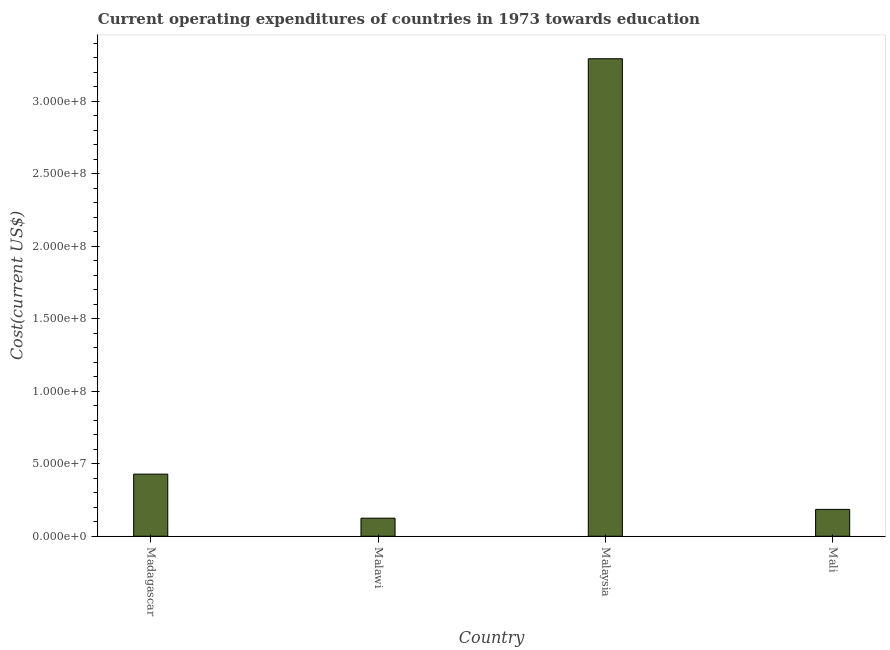Does the graph contain any zero values?
Offer a terse response. No. What is the title of the graph?
Give a very brief answer. Current operating expenditures of countries in 1973 towards education. What is the label or title of the X-axis?
Provide a short and direct response. Country. What is the label or title of the Y-axis?
Provide a short and direct response. Cost(current US$). What is the education expenditure in Malawi?
Your response must be concise. 1.25e+07. Across all countries, what is the maximum education expenditure?
Offer a very short reply. 3.29e+08. Across all countries, what is the minimum education expenditure?
Make the answer very short. 1.25e+07. In which country was the education expenditure maximum?
Make the answer very short. Malaysia. In which country was the education expenditure minimum?
Provide a succinct answer. Malawi. What is the sum of the education expenditure?
Ensure brevity in your answer.  4.03e+08. What is the difference between the education expenditure in Madagascar and Malawi?
Your response must be concise. 3.04e+07. What is the average education expenditure per country?
Your answer should be very brief. 1.01e+08. What is the median education expenditure?
Ensure brevity in your answer.  3.07e+07. In how many countries, is the education expenditure greater than 220000000 US$?
Provide a succinct answer. 1. What is the ratio of the education expenditure in Madagascar to that in Malawi?
Ensure brevity in your answer.  3.44. Is the difference between the education expenditure in Madagascar and Mali greater than the difference between any two countries?
Keep it short and to the point. No. What is the difference between the highest and the second highest education expenditure?
Give a very brief answer. 2.87e+08. What is the difference between the highest and the lowest education expenditure?
Make the answer very short. 3.17e+08. In how many countries, is the education expenditure greater than the average education expenditure taken over all countries?
Give a very brief answer. 1. How many bars are there?
Offer a terse response. 4. What is the Cost(current US$) of Madagascar?
Your response must be concise. 4.29e+07. What is the Cost(current US$) of Malawi?
Your response must be concise. 1.25e+07. What is the Cost(current US$) in Malaysia?
Your answer should be very brief. 3.29e+08. What is the Cost(current US$) of Mali?
Provide a succinct answer. 1.85e+07. What is the difference between the Cost(current US$) in Madagascar and Malawi?
Give a very brief answer. 3.04e+07. What is the difference between the Cost(current US$) in Madagascar and Malaysia?
Provide a succinct answer. -2.87e+08. What is the difference between the Cost(current US$) in Madagascar and Mali?
Keep it short and to the point. 2.43e+07. What is the difference between the Cost(current US$) in Malawi and Malaysia?
Provide a succinct answer. -3.17e+08. What is the difference between the Cost(current US$) in Malawi and Mali?
Your answer should be compact. -6.06e+06. What is the difference between the Cost(current US$) in Malaysia and Mali?
Your answer should be compact. 3.11e+08. What is the ratio of the Cost(current US$) in Madagascar to that in Malawi?
Your answer should be compact. 3.44. What is the ratio of the Cost(current US$) in Madagascar to that in Malaysia?
Offer a very short reply. 0.13. What is the ratio of the Cost(current US$) in Madagascar to that in Mali?
Offer a terse response. 2.31. What is the ratio of the Cost(current US$) in Malawi to that in Malaysia?
Offer a terse response. 0.04. What is the ratio of the Cost(current US$) in Malawi to that in Mali?
Ensure brevity in your answer.  0.67. What is the ratio of the Cost(current US$) in Malaysia to that in Mali?
Your response must be concise. 17.78. 